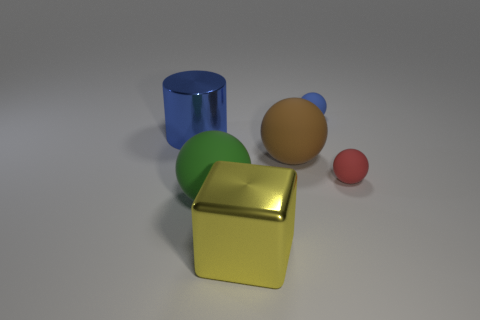What size is the blue sphere that is made of the same material as the big brown object?
Make the answer very short. Small. There is a tiny object that is in front of the tiny blue matte thing; does it have the same shape as the yellow thing?
Offer a very short reply. No. How many green spheres are the same size as the green thing?
Give a very brief answer. 0. What is the shape of the object that is the same color as the big cylinder?
Give a very brief answer. Sphere. Are there any big objects to the left of the big matte sphere in front of the small red matte thing?
Your response must be concise. Yes. How many things are balls that are in front of the large blue shiny cylinder or brown rubber things?
Give a very brief answer. 3. What number of yellow cylinders are there?
Make the answer very short. 0. There is a big brown thing that is the same material as the small blue ball; what is its shape?
Offer a terse response. Sphere. What is the size of the thing that is on the left side of the green object behind the large yellow metallic object?
Make the answer very short. Large. What number of objects are shiny objects behind the yellow metal thing or rubber spheres that are in front of the red matte sphere?
Provide a short and direct response. 2. 